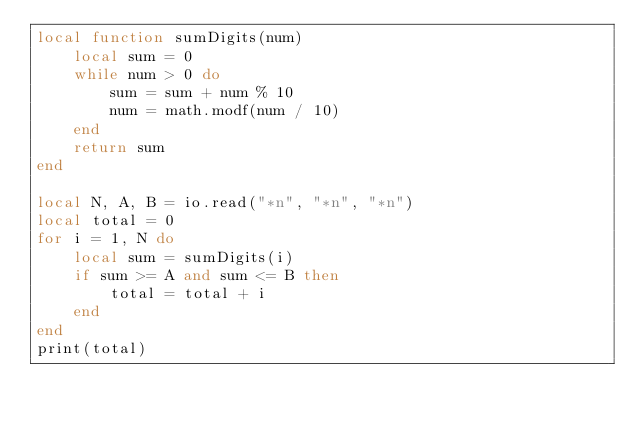Convert code to text. <code><loc_0><loc_0><loc_500><loc_500><_Lua_>local function sumDigits(num)
    local sum = 0
    while num > 0 do
        sum = sum + num % 10
        num = math.modf(num / 10)
    end
    return sum
end

local N, A, B = io.read("*n", "*n", "*n")
local total = 0
for i = 1, N do
    local sum = sumDigits(i)
    if sum >= A and sum <= B then
        total = total + i
    end
end
print(total)</code> 